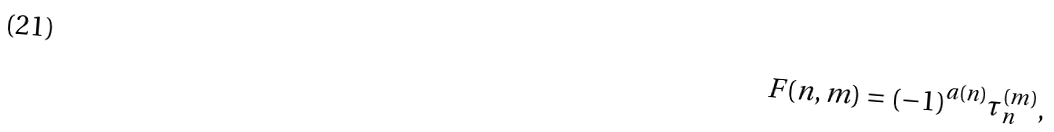Convert formula to latex. <formula><loc_0><loc_0><loc_500><loc_500>F ( n , m ) = ( - 1 ) ^ { a ( n ) } \tau ^ { ( m ) } _ { n } ,</formula> 